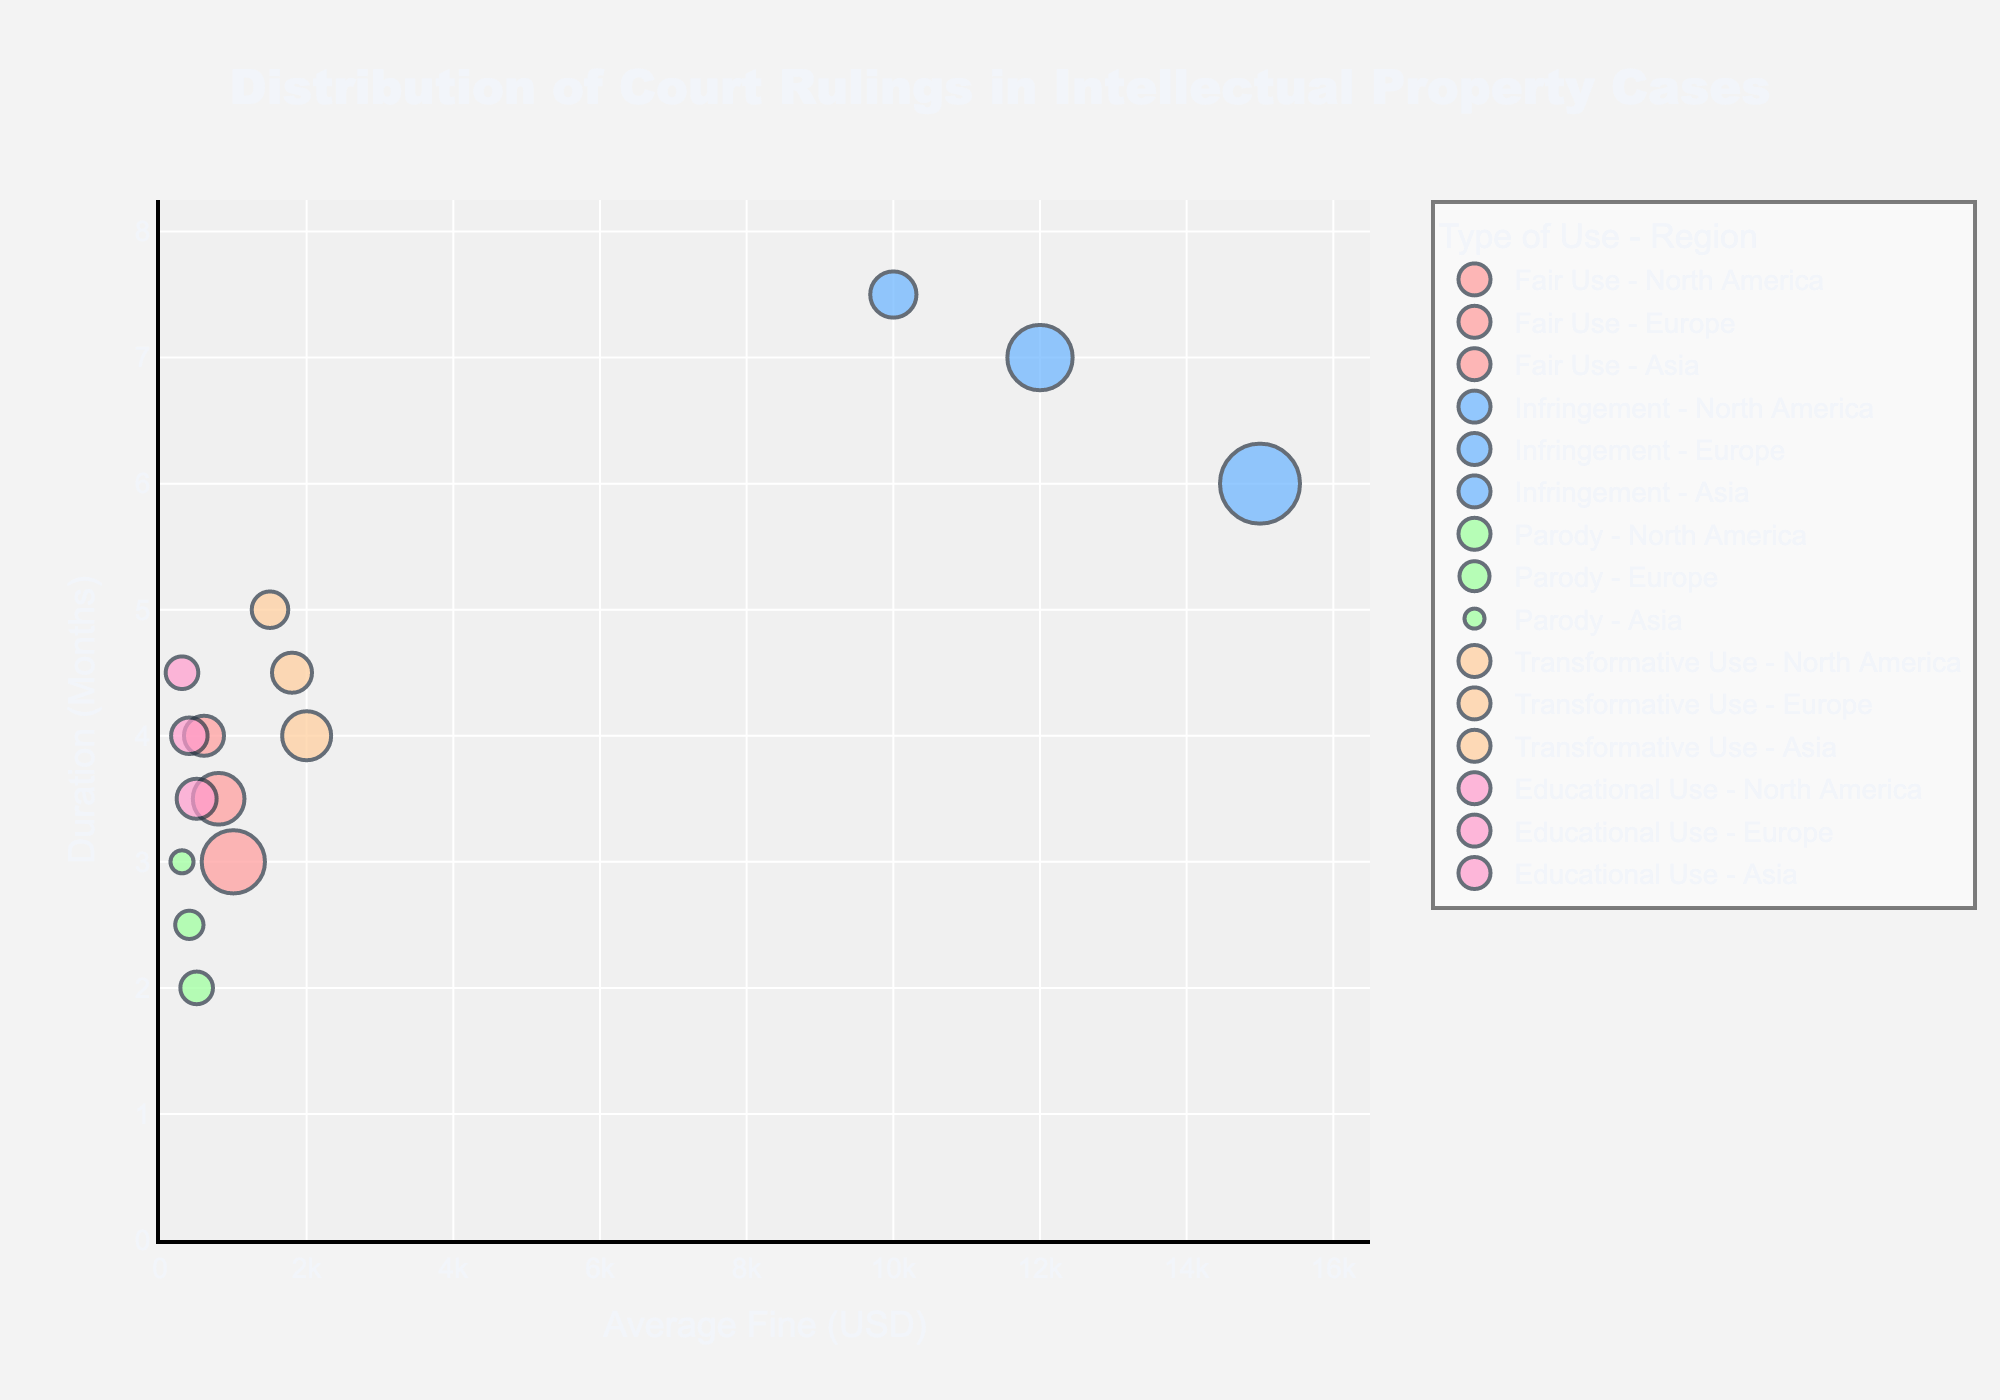What's the title of the figure? The title of the figure can be found at the top, centered.
Answer: Distribution of Court Rulings in Intellectual Property Cases Which region has the highest number of infringement rulings? The size of the bubbles indicates the number of rulings. Look for the largest bubble among infringement types.
Answer: North America What is the average fine for transformative use cases in Europe? Locate Europe on the x-axis for transformative use and read the average fine value.
Answer: $1,800 Which type of use in Asia has the shortest duration of rulings? Look at the y-axis for Asian regions and observe the lowest point.
Answer: Parody How many court rulings in total are represented for fair use? Add the number of rulings for all regions under fair use (75 + 50 + 30).
Answer: 155 What is the difference in average fine between infringement in North America and Asia? Find the average fines for infringement in North America and Asia, then subtract the two values (15,000 - 10,000).
Answer: $5,000 Which region has the longest average duration for educational use? Compare the average duration for educational use across all regions and pick the highest value.
Answer: Asia Are there more parody rulings or transformative use rulings in Europe? Compare the number of rulings for parody and transformative use in Europe.
Answer: Transformative use What is the combined average fine for fair use in North America and Europe? Sum the average fines for fair use in North America and Europe, then divide by 2 ((1000 + 800) / 2).
Answer: $900 Which type of use generally has the smallest average fine across all regions? Compare the average fines for each type of use across all regions.
Answer: Parody 